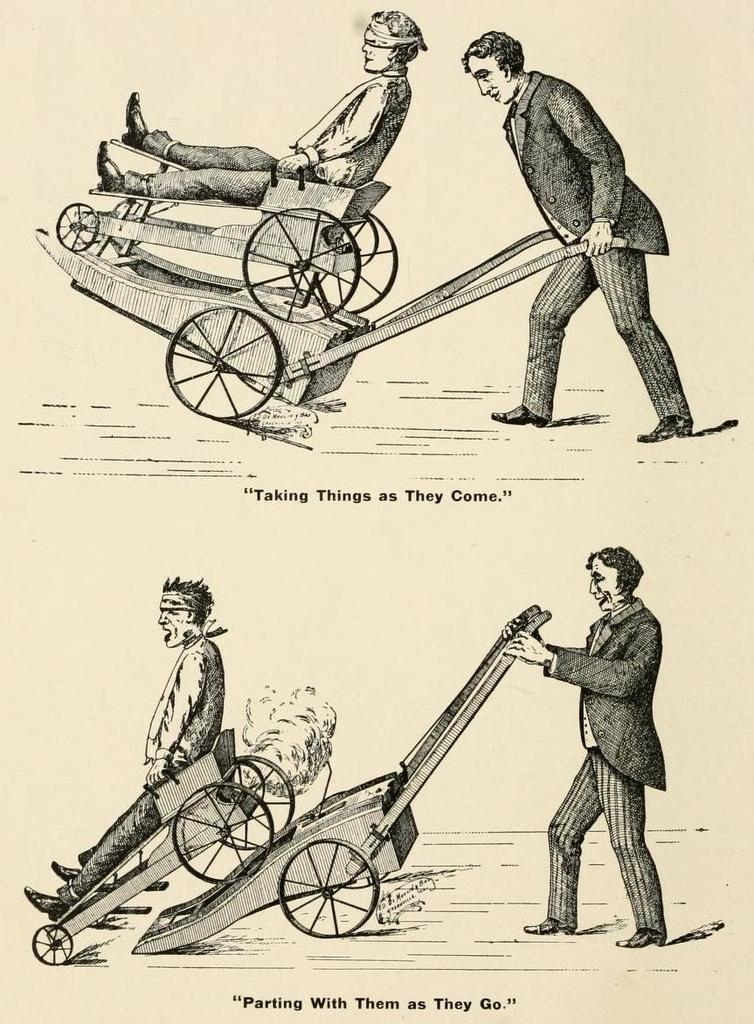How many people are in the image? There are two persons in the image. What are the people doing in the image? One person is on the cart, and another person is holding the cart with his hand. What can be seen under the images? There is text visible under the images. How many snails can be seen crawling on the cart in the image? There are no snails present in the image; it features two persons interacting with a cart. What type of sticks are being used by the person holding the cart? There are no sticks visible in the image; the person is holding the cart with his hand. 